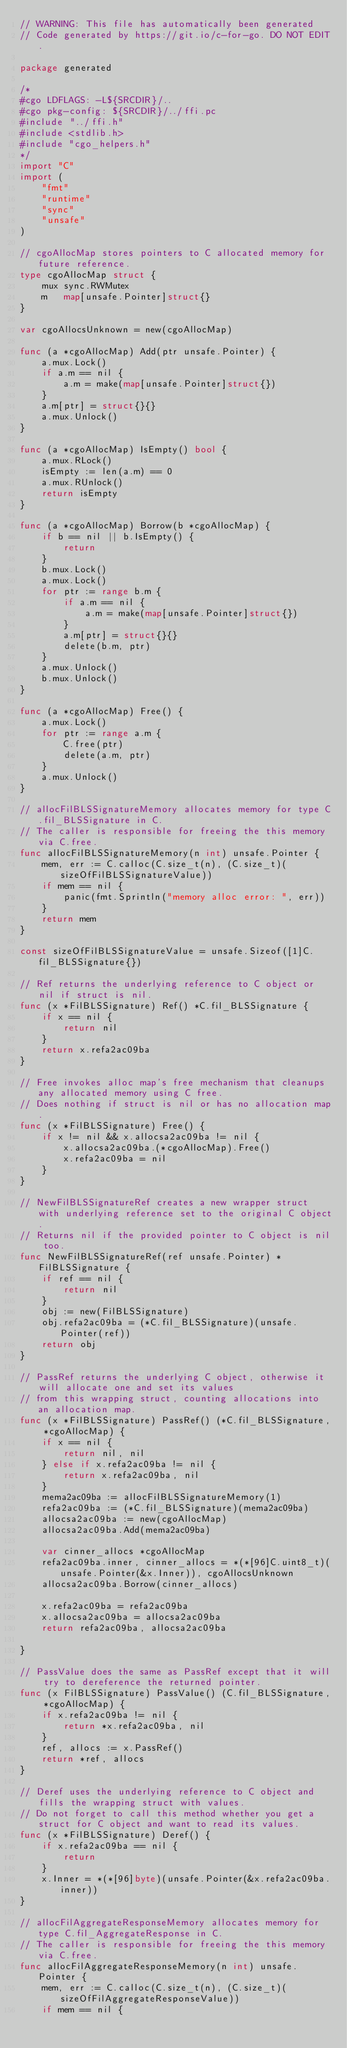Convert code to text. <code><loc_0><loc_0><loc_500><loc_500><_Go_>// WARNING: This file has automatically been generated
// Code generated by https://git.io/c-for-go. DO NOT EDIT.

package generated

/*
#cgo LDFLAGS: -L${SRCDIR}/..
#cgo pkg-config: ${SRCDIR}/../ffi.pc
#include "../ffi.h"
#include <stdlib.h>
#include "cgo_helpers.h"
*/
import "C"
import (
	"fmt"
	"runtime"
	"sync"
	"unsafe"
)

// cgoAllocMap stores pointers to C allocated memory for future reference.
type cgoAllocMap struct {
	mux sync.RWMutex
	m   map[unsafe.Pointer]struct{}
}

var cgoAllocsUnknown = new(cgoAllocMap)

func (a *cgoAllocMap) Add(ptr unsafe.Pointer) {
	a.mux.Lock()
	if a.m == nil {
		a.m = make(map[unsafe.Pointer]struct{})
	}
	a.m[ptr] = struct{}{}
	a.mux.Unlock()
}

func (a *cgoAllocMap) IsEmpty() bool {
	a.mux.RLock()
	isEmpty := len(a.m) == 0
	a.mux.RUnlock()
	return isEmpty
}

func (a *cgoAllocMap) Borrow(b *cgoAllocMap) {
	if b == nil || b.IsEmpty() {
		return
	}
	b.mux.Lock()
	a.mux.Lock()
	for ptr := range b.m {
		if a.m == nil {
			a.m = make(map[unsafe.Pointer]struct{})
		}
		a.m[ptr] = struct{}{}
		delete(b.m, ptr)
	}
	a.mux.Unlock()
	b.mux.Unlock()
}

func (a *cgoAllocMap) Free() {
	a.mux.Lock()
	for ptr := range a.m {
		C.free(ptr)
		delete(a.m, ptr)
	}
	a.mux.Unlock()
}

// allocFilBLSSignatureMemory allocates memory for type C.fil_BLSSignature in C.
// The caller is responsible for freeing the this memory via C.free.
func allocFilBLSSignatureMemory(n int) unsafe.Pointer {
	mem, err := C.calloc(C.size_t(n), (C.size_t)(sizeOfFilBLSSignatureValue))
	if mem == nil {
		panic(fmt.Sprintln("memory alloc error: ", err))
	}
	return mem
}

const sizeOfFilBLSSignatureValue = unsafe.Sizeof([1]C.fil_BLSSignature{})

// Ref returns the underlying reference to C object or nil if struct is nil.
func (x *FilBLSSignature) Ref() *C.fil_BLSSignature {
	if x == nil {
		return nil
	}
	return x.refa2ac09ba
}

// Free invokes alloc map's free mechanism that cleanups any allocated memory using C free.
// Does nothing if struct is nil or has no allocation map.
func (x *FilBLSSignature) Free() {
	if x != nil && x.allocsa2ac09ba != nil {
		x.allocsa2ac09ba.(*cgoAllocMap).Free()
		x.refa2ac09ba = nil
	}
}

// NewFilBLSSignatureRef creates a new wrapper struct with underlying reference set to the original C object.
// Returns nil if the provided pointer to C object is nil too.
func NewFilBLSSignatureRef(ref unsafe.Pointer) *FilBLSSignature {
	if ref == nil {
		return nil
	}
	obj := new(FilBLSSignature)
	obj.refa2ac09ba = (*C.fil_BLSSignature)(unsafe.Pointer(ref))
	return obj
}

// PassRef returns the underlying C object, otherwise it will allocate one and set its values
// from this wrapping struct, counting allocations into an allocation map.
func (x *FilBLSSignature) PassRef() (*C.fil_BLSSignature, *cgoAllocMap) {
	if x == nil {
		return nil, nil
	} else if x.refa2ac09ba != nil {
		return x.refa2ac09ba, nil
	}
	mema2ac09ba := allocFilBLSSignatureMemory(1)
	refa2ac09ba := (*C.fil_BLSSignature)(mema2ac09ba)
	allocsa2ac09ba := new(cgoAllocMap)
	allocsa2ac09ba.Add(mema2ac09ba)

	var cinner_allocs *cgoAllocMap
	refa2ac09ba.inner, cinner_allocs = *(*[96]C.uint8_t)(unsafe.Pointer(&x.Inner)), cgoAllocsUnknown
	allocsa2ac09ba.Borrow(cinner_allocs)

	x.refa2ac09ba = refa2ac09ba
	x.allocsa2ac09ba = allocsa2ac09ba
	return refa2ac09ba, allocsa2ac09ba

}

// PassValue does the same as PassRef except that it will try to dereference the returned pointer.
func (x FilBLSSignature) PassValue() (C.fil_BLSSignature, *cgoAllocMap) {
	if x.refa2ac09ba != nil {
		return *x.refa2ac09ba, nil
	}
	ref, allocs := x.PassRef()
	return *ref, allocs
}

// Deref uses the underlying reference to C object and fills the wrapping struct with values.
// Do not forget to call this method whether you get a struct for C object and want to read its values.
func (x *FilBLSSignature) Deref() {
	if x.refa2ac09ba == nil {
		return
	}
	x.Inner = *(*[96]byte)(unsafe.Pointer(&x.refa2ac09ba.inner))
}

// allocFilAggregateResponseMemory allocates memory for type C.fil_AggregateResponse in C.
// The caller is responsible for freeing the this memory via C.free.
func allocFilAggregateResponseMemory(n int) unsafe.Pointer {
	mem, err := C.calloc(C.size_t(n), (C.size_t)(sizeOfFilAggregateResponseValue))
	if mem == nil {</code> 